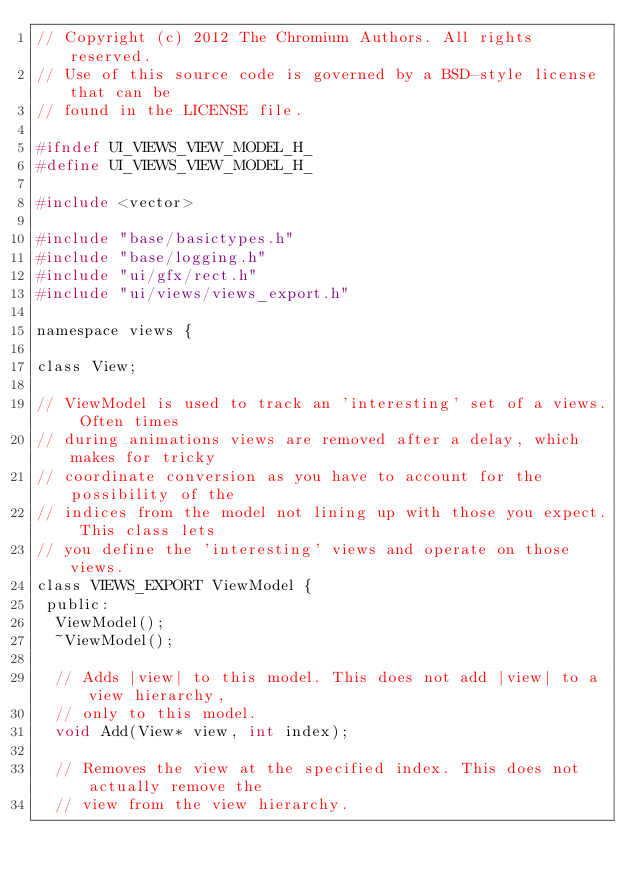Convert code to text. <code><loc_0><loc_0><loc_500><loc_500><_C_>// Copyright (c) 2012 The Chromium Authors. All rights reserved.
// Use of this source code is governed by a BSD-style license that can be
// found in the LICENSE file.

#ifndef UI_VIEWS_VIEW_MODEL_H_
#define UI_VIEWS_VIEW_MODEL_H_

#include <vector>

#include "base/basictypes.h"
#include "base/logging.h"
#include "ui/gfx/rect.h"
#include "ui/views/views_export.h"

namespace views {

class View;

// ViewModel is used to track an 'interesting' set of a views. Often times
// during animations views are removed after a delay, which makes for tricky
// coordinate conversion as you have to account for the possibility of the
// indices from the model not lining up with those you expect. This class lets
// you define the 'interesting' views and operate on those views.
class VIEWS_EXPORT ViewModel {
 public:
  ViewModel();
  ~ViewModel();

  // Adds |view| to this model. This does not add |view| to a view hierarchy,
  // only to this model.
  void Add(View* view, int index);

  // Removes the view at the specified index. This does not actually remove the
  // view from the view hierarchy.</code> 